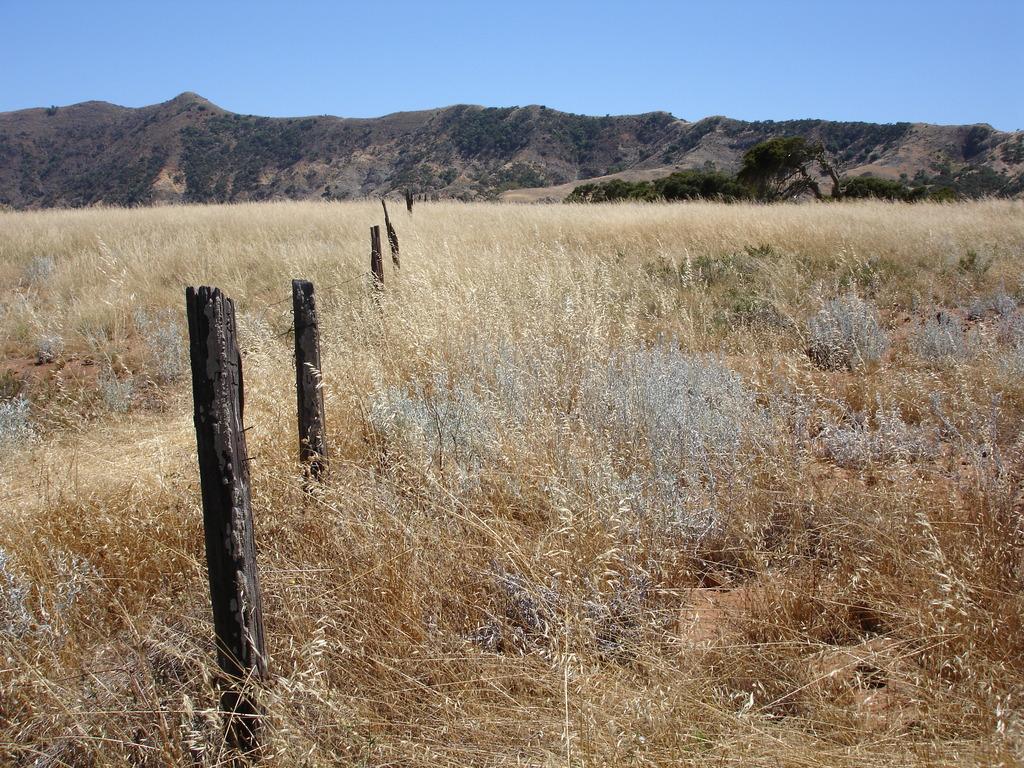Could you give a brief overview of what you see in this image? In the center of the image there is dry grass. In the background of the image there are mountains. There is a wooden fencing. At the top of the image there is sky. 